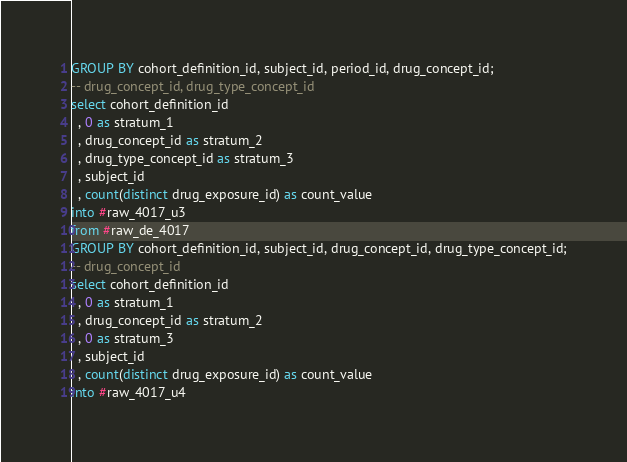<code> <loc_0><loc_0><loc_500><loc_500><_SQL_>GROUP BY cohort_definition_id, subject_id, period_id, drug_concept_id;
-- drug_concept_id, drug_type_concept_id
select cohort_definition_id
  , 0 as stratum_1
  , drug_concept_id as stratum_2
  , drug_type_concept_id as stratum_3
  , subject_id
  , count(distinct drug_exposure_id) as count_value
into #raw_4017_u3
from #raw_de_4017
GROUP BY cohort_definition_id, subject_id, drug_concept_id, drug_type_concept_id;
-- drug_concept_id
select cohort_definition_id
  , 0 as stratum_1
  , drug_concept_id as stratum_2
  , 0 as stratum_3
  , subject_id
  , count(distinct drug_exposure_id) as count_value
into #raw_4017_u4</code> 